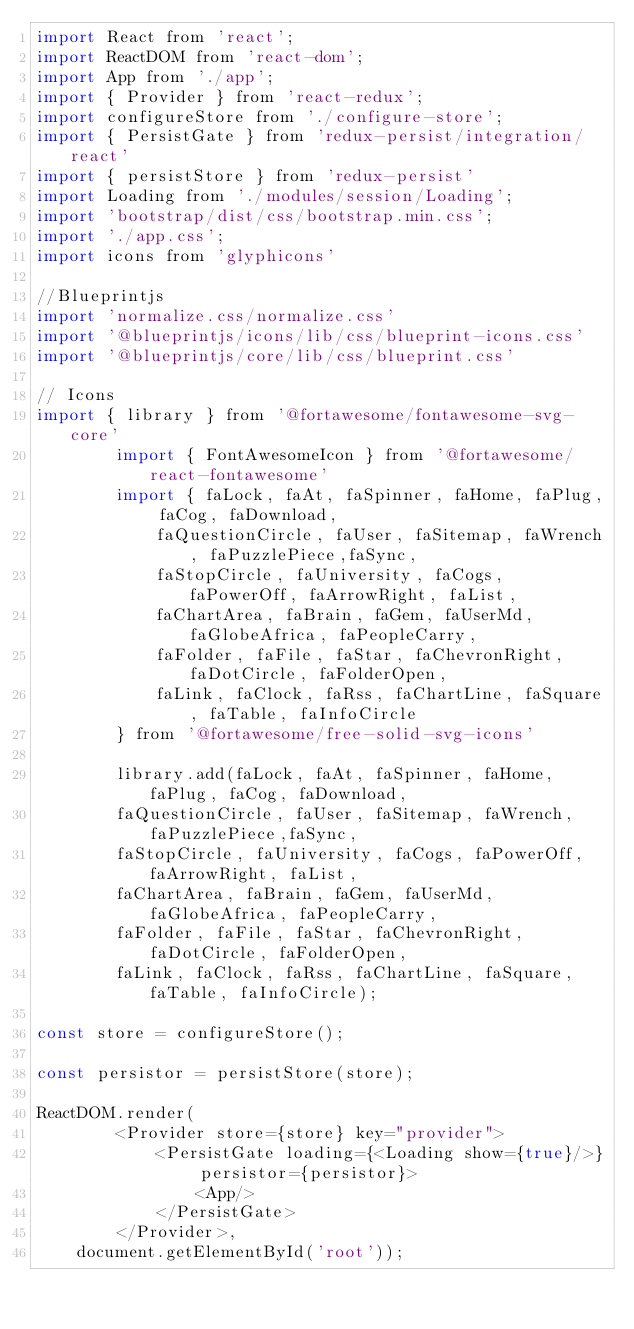Convert code to text. <code><loc_0><loc_0><loc_500><loc_500><_JavaScript_>import React from 'react';
import ReactDOM from 'react-dom';
import App from './app';
import { Provider } from 'react-redux';
import configureStore from './configure-store';
import { PersistGate } from 'redux-persist/integration/react'
import { persistStore } from 'redux-persist'
import Loading from './modules/session/Loading';
import 'bootstrap/dist/css/bootstrap.min.css';
import './app.css';
import icons from 'glyphicons'

//Blueprintjs
import 'normalize.css/normalize.css'
import '@blueprintjs/icons/lib/css/blueprint-icons.css'
import '@blueprintjs/core/lib/css/blueprint.css'

// Icons
import { library } from '@fortawesome/fontawesome-svg-core'
        import { FontAwesomeIcon } from '@fortawesome/react-fontawesome'
        import { faLock, faAt, faSpinner, faHome, faPlug, faCog, faDownload,
            faQuestionCircle, faUser, faSitemap, faWrench, faPuzzlePiece,faSync,
            faStopCircle, faUniversity, faCogs, faPowerOff, faArrowRight, faList,
            faChartArea, faBrain, faGem, faUserMd, faGlobeAfrica, faPeopleCarry,
            faFolder, faFile, faStar, faChevronRight, faDotCircle, faFolderOpen,
            faLink, faClock, faRss, faChartLine, faSquare, faTable, faInfoCircle
        } from '@fortawesome/free-solid-svg-icons'

        library.add(faLock, faAt, faSpinner, faHome, faPlug, faCog, faDownload,
        faQuestionCircle, faUser, faSitemap, faWrench, faPuzzlePiece,faSync,
        faStopCircle, faUniversity, faCogs, faPowerOff, faArrowRight, faList,
        faChartArea, faBrain, faGem, faUserMd, faGlobeAfrica, faPeopleCarry,
        faFolder, faFile, faStar, faChevronRight, faDotCircle, faFolderOpen, 
        faLink, faClock, faRss, faChartLine, faSquare, faTable, faInfoCircle);

const store = configureStore();

const persistor = persistStore(store);

ReactDOM.render(
        <Provider store={store} key="provider">
            <PersistGate loading={<Loading show={true}/>} persistor={persistor}>
                <App/>
            </PersistGate>
        </Provider>,
    document.getElementById('root'));
</code> 